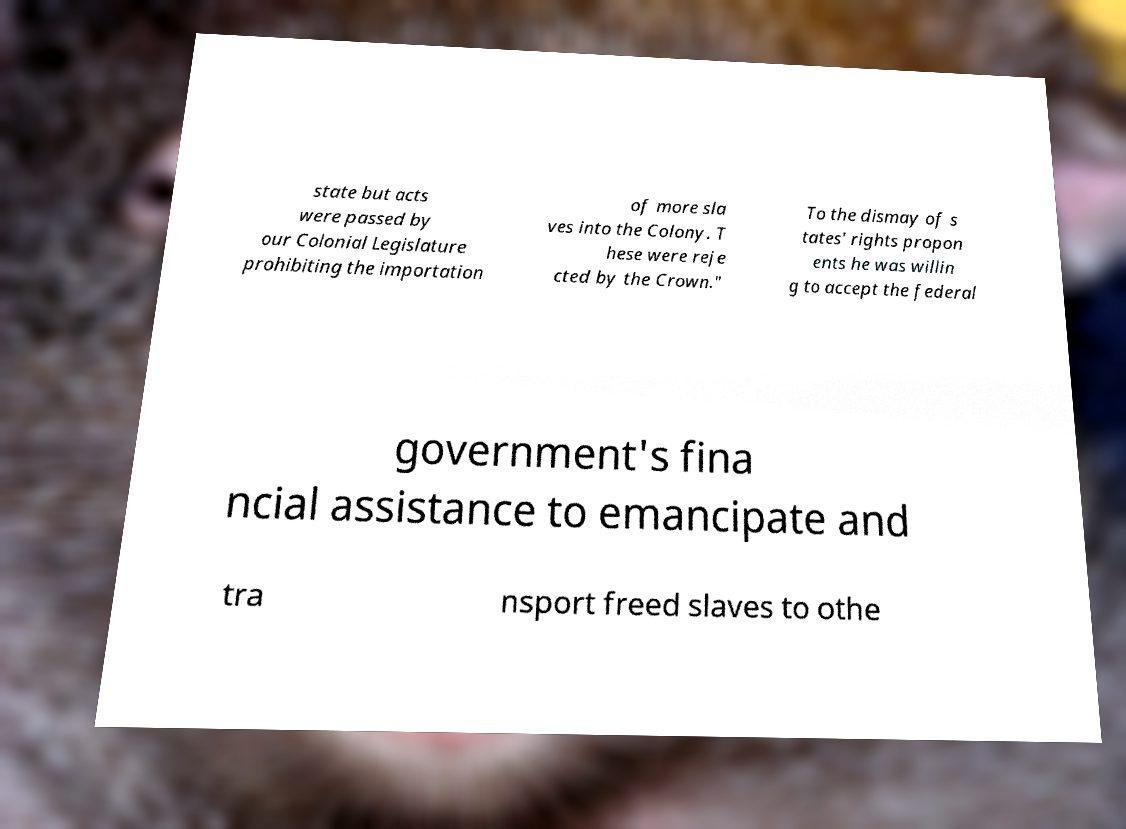There's text embedded in this image that I need extracted. Can you transcribe it verbatim? state but acts were passed by our Colonial Legislature prohibiting the importation of more sla ves into the Colony. T hese were reje cted by the Crown." To the dismay of s tates' rights propon ents he was willin g to accept the federal government's fina ncial assistance to emancipate and tra nsport freed slaves to othe 